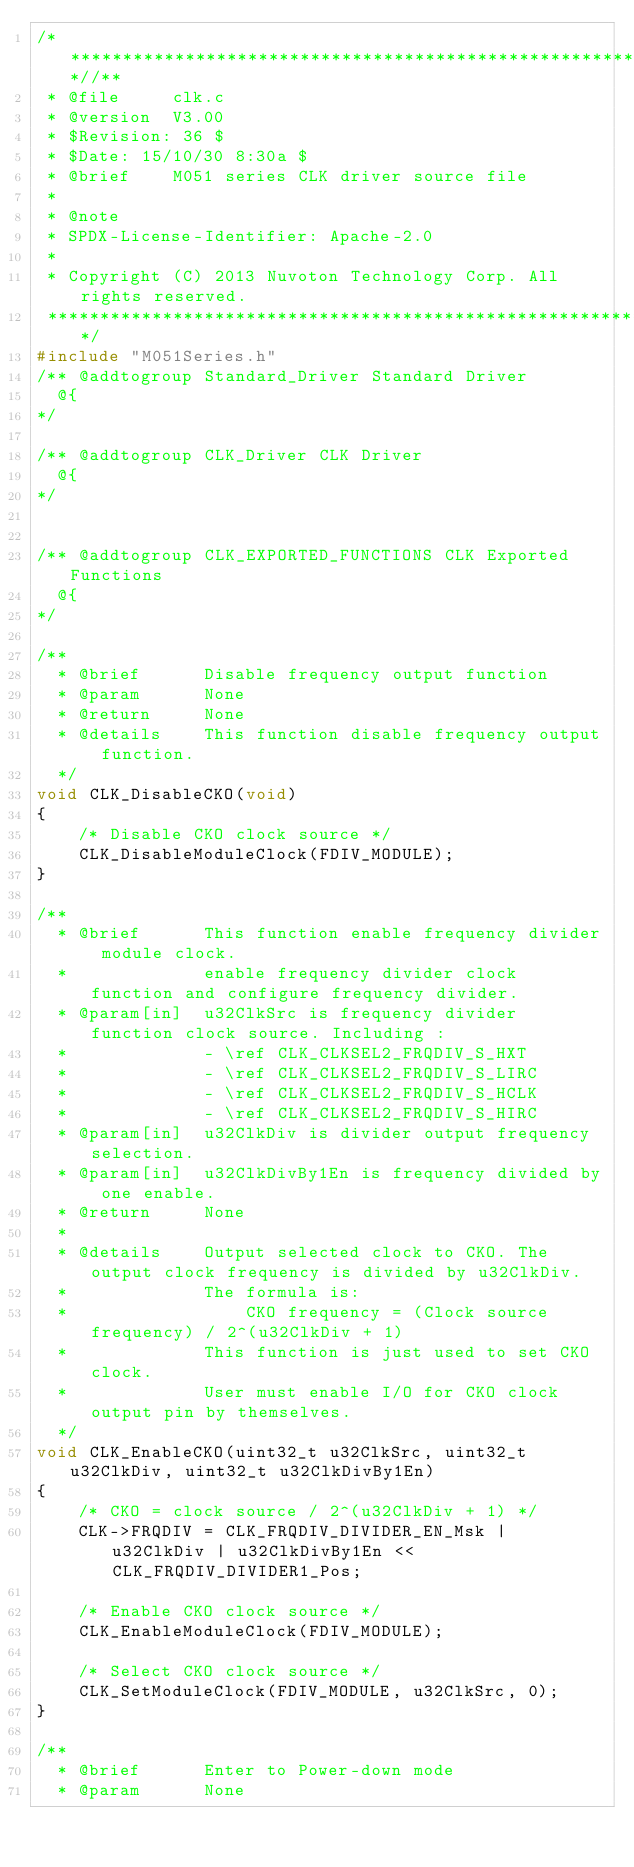<code> <loc_0><loc_0><loc_500><loc_500><_C_>/**************************************************************************//**
 * @file     clk.c
 * @version  V3.00
 * $Revision: 36 $
 * $Date: 15/10/30 8:30a $
 * @brief    M051 series CLK driver source file
 *
 * @note
 * SPDX-License-Identifier: Apache-2.0
 *
 * Copyright (C) 2013 Nuvoton Technology Corp. All rights reserved.
 *****************************************************************************/
#include "M051Series.h"
/** @addtogroup Standard_Driver Standard Driver
  @{
*/

/** @addtogroup CLK_Driver CLK Driver
  @{
*/


/** @addtogroup CLK_EXPORTED_FUNCTIONS CLK Exported Functions
  @{
*/

/**
  * @brief      Disable frequency output function
  * @param      None  
  * @return     None
  * @details    This function disable frequency output function. 
  */
void CLK_DisableCKO(void)
{
    /* Disable CKO clock source */
    CLK_DisableModuleClock(FDIV_MODULE);
}

/**
  * @brief      This function enable frequency divider module clock.
  *             enable frequency divider clock function and configure frequency divider.
  * @param[in]  u32ClkSrc is frequency divider function clock source. Including :
  *             - \ref CLK_CLKSEL2_FRQDIV_S_HXT
  *             - \ref CLK_CLKSEL2_FRQDIV_S_LIRC
  *             - \ref CLK_CLKSEL2_FRQDIV_S_HCLK
  *             - \ref CLK_CLKSEL2_FRQDIV_S_HIRC
  * @param[in]  u32ClkDiv is divider output frequency selection.
  * @param[in]  u32ClkDivBy1En is frequency divided by one enable.
  * @return     None
  *
  * @details    Output selected clock to CKO. The output clock frequency is divided by u32ClkDiv.
  *             The formula is:
  *                 CKO frequency = (Clock source frequency) / 2^(u32ClkDiv + 1)
  *             This function is just used to set CKO clock.
  *             User must enable I/O for CKO clock output pin by themselves.
  */
void CLK_EnableCKO(uint32_t u32ClkSrc, uint32_t u32ClkDiv, uint32_t u32ClkDivBy1En)
{
    /* CKO = clock source / 2^(u32ClkDiv + 1) */
    CLK->FRQDIV = CLK_FRQDIV_DIVIDER_EN_Msk | u32ClkDiv | u32ClkDivBy1En << CLK_FRQDIV_DIVIDER1_Pos;

    /* Enable CKO clock source */
    CLK_EnableModuleClock(FDIV_MODULE);

    /* Select CKO clock source */
    CLK_SetModuleClock(FDIV_MODULE, u32ClkSrc, 0);
}

/**
  * @brief      Enter to Power-down mode
  * @param      None  </code> 